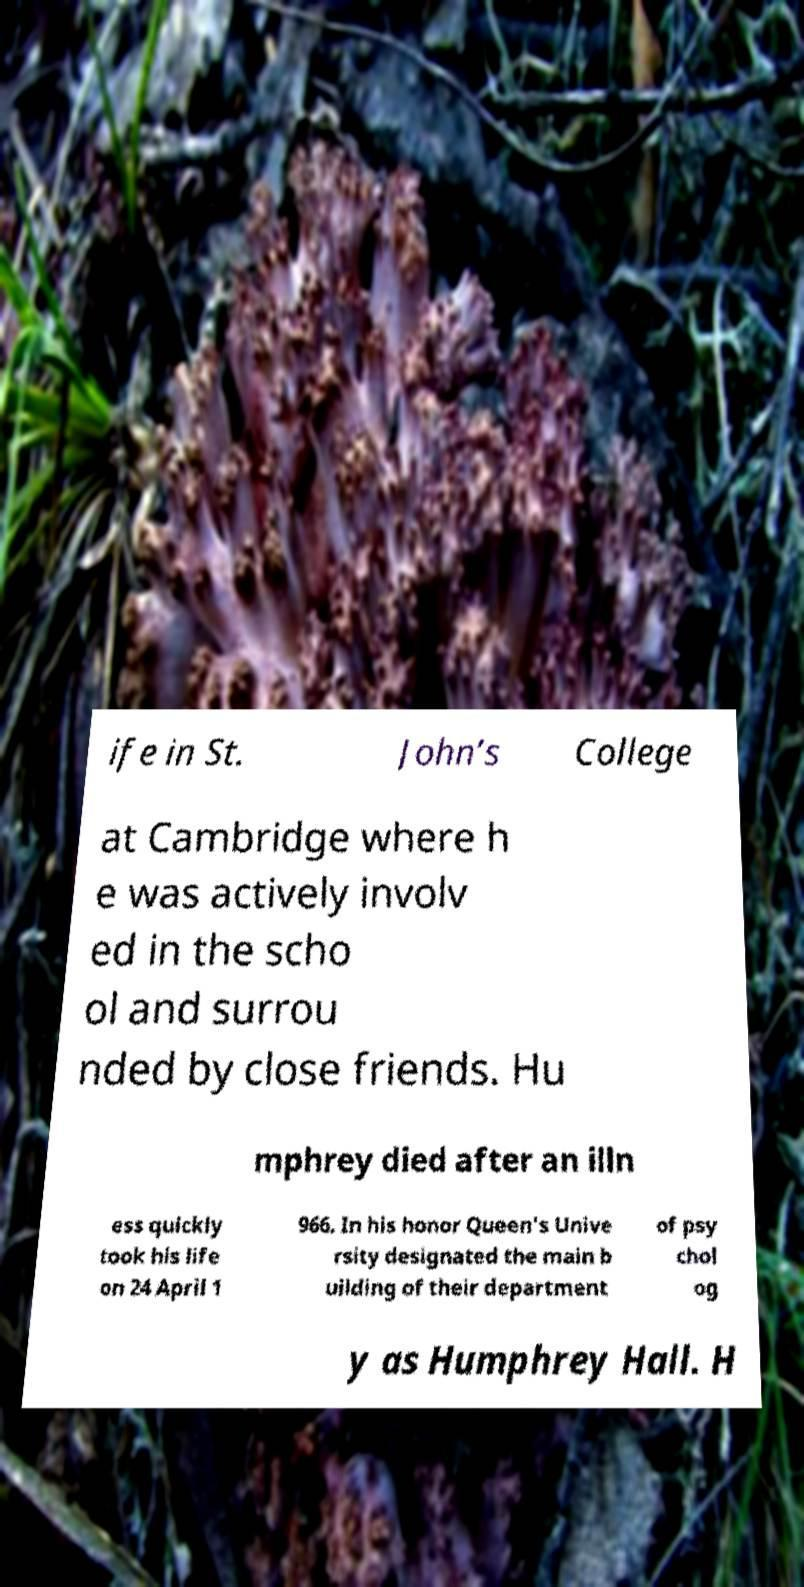I need the written content from this picture converted into text. Can you do that? ife in St. John’s College at Cambridge where h e was actively involv ed in the scho ol and surrou nded by close friends. Hu mphrey died after an illn ess quickly took his life on 24 April 1 966. In his honor Queen's Unive rsity designated the main b uilding of their department of psy chol og y as Humphrey Hall. H 